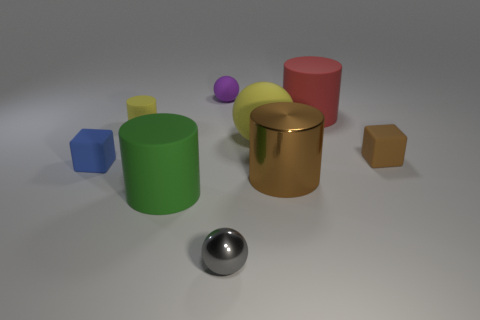What could be the material of the shiny gold cylinder in the middle? The shiny gold cylinder appears to be made of a reflective metal with a polished gold finish that suggests it could be brass or a brass-like material. Could you use it for any particular function? Given its simple geometry and reflective surface, it might be a decorative piece or could serve as a container or a pedestal in a display due to its sturdy shape. Its exact function would depend on the context in which it is used. 